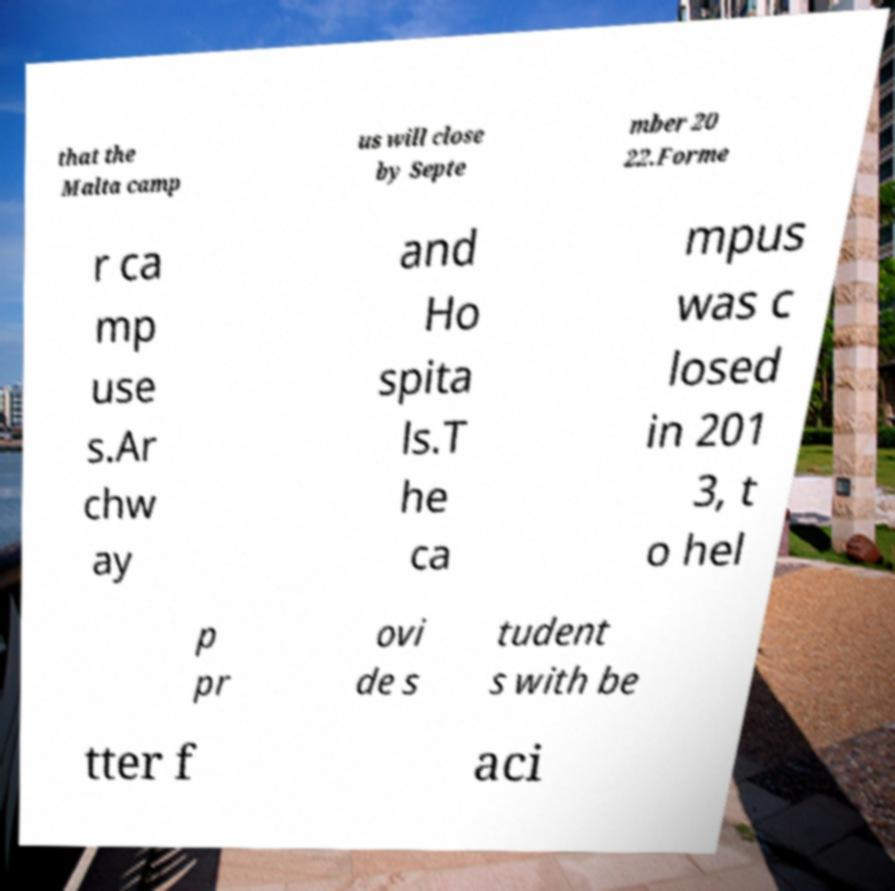Please read and relay the text visible in this image. What does it say? that the Malta camp us will close by Septe mber 20 22.Forme r ca mp use s.Ar chw ay and Ho spita ls.T he ca mpus was c losed in 201 3, t o hel p pr ovi de s tudent s with be tter f aci 